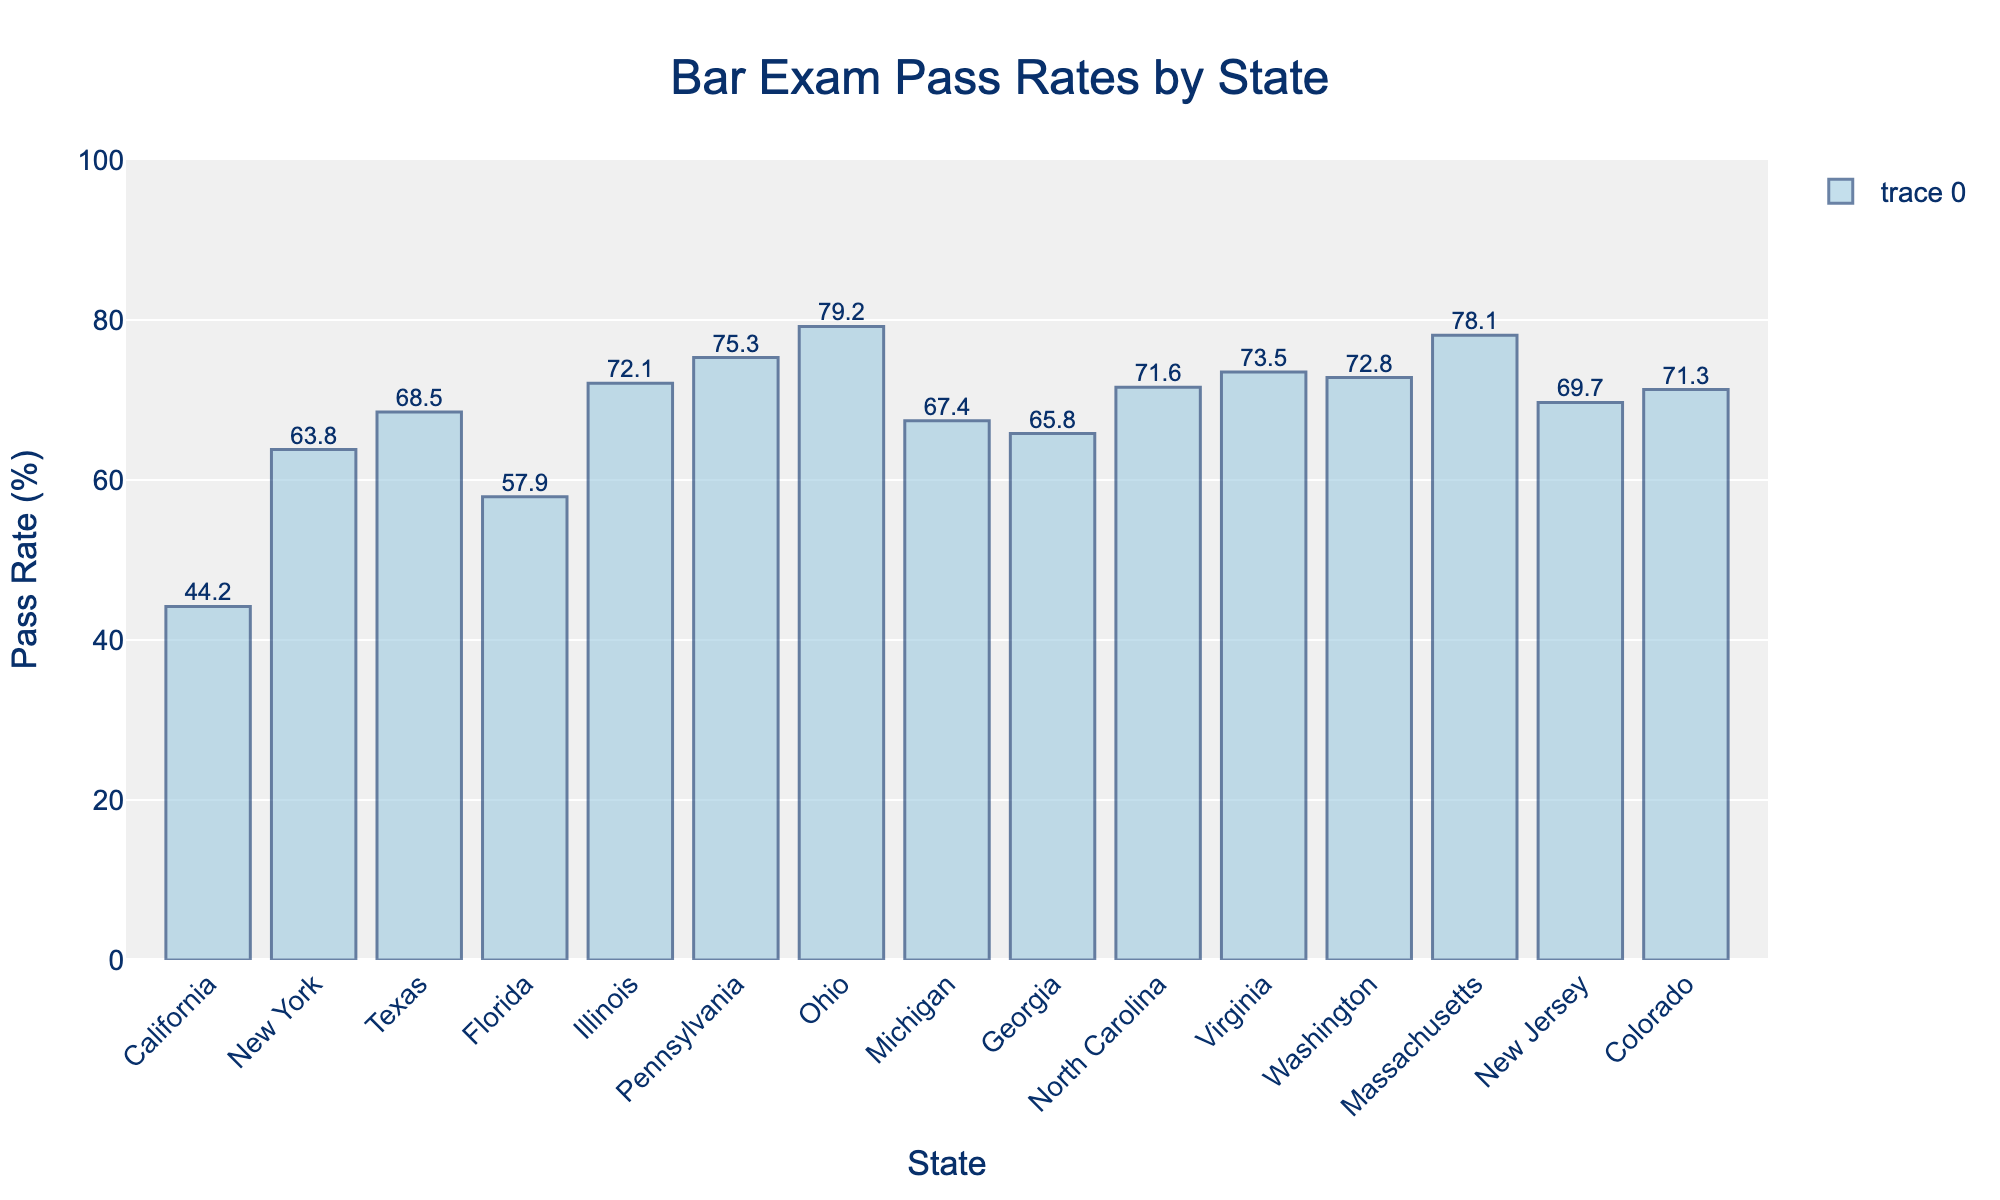Which state has the highest bar exam pass rate? Pennsylvania has the highest pass rate of 75.3% as shown by the tallest bar.
Answer: Pennsylvania Which state has the lowest bar exam pass rate? California has the lowest pass rate of 44.2%, indicated by the shortest bar.
Answer: California Which states have a pass rate higher than 70% and how many are there? Illinois, Pennsylvania, Ohio, Virginia, Washington, Massachusetts, New Jersey, and Colorado have pass rates higher than 70%. There are 8 states in total.
Answer: 8 What is the difference between the pass rates of Ohio and California? Ohio has a pass rate of 79.2% and California has 44.2%. The difference is 79.2 - 44.2 = 35.
Answer: 35 Which state has a marginally higher pass rate between Massachusetts and New Jersey? Massachusetts has a pass rate of 78.1% and New Jersey has 69.7%; Massachusetts has a higher pass rate.
Answer: Massachusetts What is the average pass rate of the states listed? Sum the pass rates of all states (44.2 + 63.8 + 68.5 + 57.9 + 72.1 + 75.3 + 79.2 + 67.4 + 65.8 + 71.6 + 73.5 + 72.8 + 78.1 + 69.7 + 71.3) which equals 1029.2. Divide by the number of states (15). The average pass rate is 1029.2 / 15 = 68.6%
Answer: 68.6% Which state has a lower pass rate: Georgia or Michigan? Georgia has a pass rate of 65.8% while Michigan has 67.4%. Therefore, Georgia has a lower pass rate.
Answer: Georgia Are there more states with pass rates above or below 70%? There are 8 states with pass rates above 70% (Illinois, Pennsylvania, Ohio, North Carolina, Virginia, Washington, Massachusetts, New Jersey, Colorado) and 7 states with pass rates below 70% (California, New York, Texas, Florida, Michigan, Georgia). Therefore, there are more states with pass rates above 70%.
Answer: Above What is the median pass rate of the states? To find the median, list the pass rates in ascending order: 44.2, 57.9, 63.8, 65.8, 67.4, 68.5, 69.7, 71.3, 71.6, 72.1, 72.8, 73.5, 75.3, 78.1, 79.2. The median is the middle value, which is 69.7.
Answer: 69.7% 